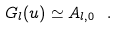Convert formula to latex. <formula><loc_0><loc_0><loc_500><loc_500>G _ { l } ( u ) \simeq A _ { l , 0 } \ .</formula> 